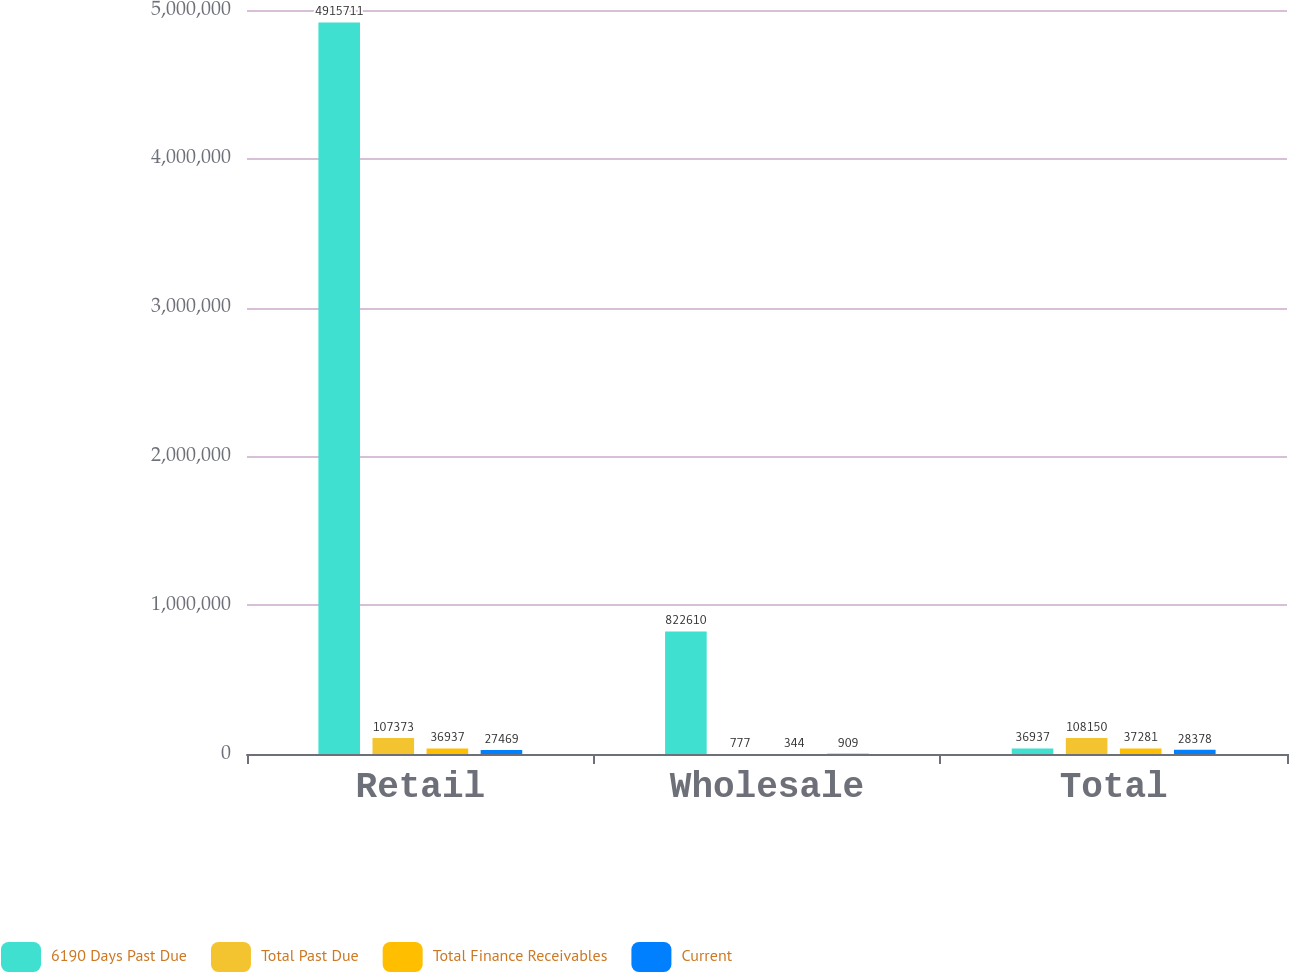Convert chart. <chart><loc_0><loc_0><loc_500><loc_500><stacked_bar_chart><ecel><fcel>Retail<fcel>Wholesale<fcel>Total<nl><fcel>6190 Days Past Due<fcel>4.91571e+06<fcel>822610<fcel>36937<nl><fcel>Total Past Due<fcel>107373<fcel>777<fcel>108150<nl><fcel>Total Finance Receivables<fcel>36937<fcel>344<fcel>37281<nl><fcel>Current<fcel>27469<fcel>909<fcel>28378<nl></chart> 